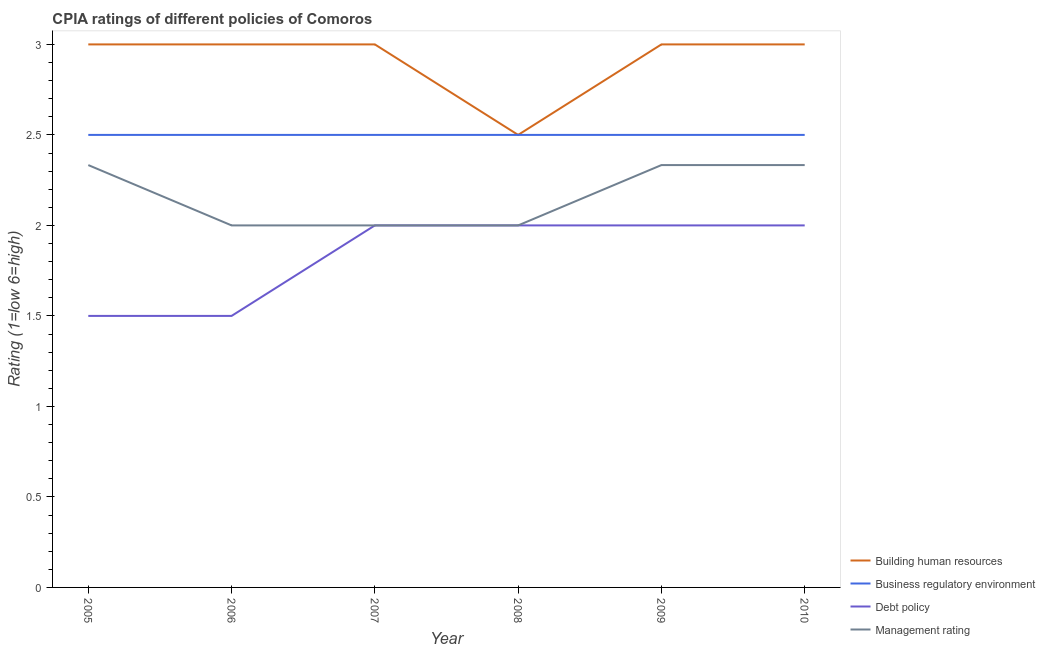How many different coloured lines are there?
Keep it short and to the point. 4. Does the line corresponding to cpia rating of building human resources intersect with the line corresponding to cpia rating of debt policy?
Your response must be concise. No. Across all years, what is the maximum cpia rating of management?
Give a very brief answer. 2.33. In which year was the cpia rating of management minimum?
Provide a short and direct response. 2006. What is the total cpia rating of debt policy in the graph?
Make the answer very short. 11. What is the difference between the cpia rating of building human resources in 2006 and that in 2009?
Offer a terse response. 0. What is the average cpia rating of debt policy per year?
Ensure brevity in your answer.  1.83. In the year 2006, what is the difference between the cpia rating of management and cpia rating of building human resources?
Make the answer very short. -1. What is the difference between the highest and the second highest cpia rating of building human resources?
Your answer should be compact. 0. Is the sum of the cpia rating of debt policy in 2006 and 2007 greater than the maximum cpia rating of management across all years?
Your answer should be very brief. Yes. Is it the case that in every year, the sum of the cpia rating of building human resources and cpia rating of business regulatory environment is greater than the cpia rating of debt policy?
Your response must be concise. Yes. Does the cpia rating of management monotonically increase over the years?
Offer a terse response. No. Is the cpia rating of debt policy strictly greater than the cpia rating of building human resources over the years?
Your answer should be compact. No. Is the cpia rating of building human resources strictly less than the cpia rating of debt policy over the years?
Make the answer very short. No. How many lines are there?
Make the answer very short. 4. What is the difference between two consecutive major ticks on the Y-axis?
Your answer should be compact. 0.5. Are the values on the major ticks of Y-axis written in scientific E-notation?
Your answer should be compact. No. Does the graph contain any zero values?
Provide a succinct answer. No. Where does the legend appear in the graph?
Your answer should be very brief. Bottom right. What is the title of the graph?
Offer a very short reply. CPIA ratings of different policies of Comoros. Does "Japan" appear as one of the legend labels in the graph?
Offer a terse response. No. What is the label or title of the X-axis?
Your answer should be very brief. Year. What is the Rating (1=low 6=high) in Debt policy in 2005?
Your answer should be compact. 1.5. What is the Rating (1=low 6=high) of Management rating in 2005?
Keep it short and to the point. 2.33. What is the Rating (1=low 6=high) of Business regulatory environment in 2006?
Keep it short and to the point. 2.5. What is the Rating (1=low 6=high) of Debt policy in 2006?
Your answer should be very brief. 1.5. What is the Rating (1=low 6=high) in Business regulatory environment in 2007?
Provide a succinct answer. 2.5. What is the Rating (1=low 6=high) in Debt policy in 2007?
Provide a short and direct response. 2. What is the Rating (1=low 6=high) in Business regulatory environment in 2008?
Offer a very short reply. 2.5. What is the Rating (1=low 6=high) in Debt policy in 2008?
Ensure brevity in your answer.  2. What is the Rating (1=low 6=high) in Management rating in 2008?
Keep it short and to the point. 2. What is the Rating (1=low 6=high) in Building human resources in 2009?
Keep it short and to the point. 3. What is the Rating (1=low 6=high) of Debt policy in 2009?
Your response must be concise. 2. What is the Rating (1=low 6=high) in Management rating in 2009?
Keep it short and to the point. 2.33. What is the Rating (1=low 6=high) in Building human resources in 2010?
Ensure brevity in your answer.  3. What is the Rating (1=low 6=high) of Debt policy in 2010?
Offer a terse response. 2. What is the Rating (1=low 6=high) of Management rating in 2010?
Provide a short and direct response. 2.33. Across all years, what is the maximum Rating (1=low 6=high) of Business regulatory environment?
Make the answer very short. 2.5. Across all years, what is the maximum Rating (1=low 6=high) of Debt policy?
Offer a terse response. 2. Across all years, what is the maximum Rating (1=low 6=high) in Management rating?
Your response must be concise. 2.33. Across all years, what is the minimum Rating (1=low 6=high) in Business regulatory environment?
Provide a succinct answer. 2.5. Across all years, what is the minimum Rating (1=low 6=high) of Management rating?
Provide a succinct answer. 2. What is the total Rating (1=low 6=high) of Building human resources in the graph?
Offer a very short reply. 17.5. What is the total Rating (1=low 6=high) of Management rating in the graph?
Provide a succinct answer. 13. What is the difference between the Rating (1=low 6=high) of Business regulatory environment in 2005 and that in 2006?
Provide a succinct answer. 0. What is the difference between the Rating (1=low 6=high) in Debt policy in 2005 and that in 2006?
Provide a succinct answer. 0. What is the difference between the Rating (1=low 6=high) of Business regulatory environment in 2005 and that in 2007?
Keep it short and to the point. 0. What is the difference between the Rating (1=low 6=high) of Debt policy in 2005 and that in 2007?
Your answer should be very brief. -0.5. What is the difference between the Rating (1=low 6=high) of Management rating in 2005 and that in 2007?
Offer a terse response. 0.33. What is the difference between the Rating (1=low 6=high) in Building human resources in 2005 and that in 2008?
Your answer should be very brief. 0.5. What is the difference between the Rating (1=low 6=high) of Business regulatory environment in 2005 and that in 2008?
Ensure brevity in your answer.  0. What is the difference between the Rating (1=low 6=high) in Debt policy in 2005 and that in 2008?
Your answer should be very brief. -0.5. What is the difference between the Rating (1=low 6=high) of Building human resources in 2005 and that in 2009?
Give a very brief answer. 0. What is the difference between the Rating (1=low 6=high) in Building human resources in 2005 and that in 2010?
Your response must be concise. 0. What is the difference between the Rating (1=low 6=high) of Debt policy in 2005 and that in 2010?
Provide a succinct answer. -0.5. What is the difference between the Rating (1=low 6=high) of Building human resources in 2006 and that in 2007?
Offer a very short reply. 0. What is the difference between the Rating (1=low 6=high) in Debt policy in 2006 and that in 2007?
Offer a very short reply. -0.5. What is the difference between the Rating (1=low 6=high) of Management rating in 2006 and that in 2007?
Offer a terse response. 0. What is the difference between the Rating (1=low 6=high) of Building human resources in 2006 and that in 2008?
Ensure brevity in your answer.  0.5. What is the difference between the Rating (1=low 6=high) in Business regulatory environment in 2006 and that in 2008?
Your answer should be very brief. 0. What is the difference between the Rating (1=low 6=high) of Debt policy in 2006 and that in 2008?
Offer a terse response. -0.5. What is the difference between the Rating (1=low 6=high) of Building human resources in 2006 and that in 2009?
Offer a very short reply. 0. What is the difference between the Rating (1=low 6=high) of Building human resources in 2006 and that in 2010?
Your response must be concise. 0. What is the difference between the Rating (1=low 6=high) in Business regulatory environment in 2007 and that in 2008?
Provide a short and direct response. 0. What is the difference between the Rating (1=low 6=high) of Building human resources in 2007 and that in 2009?
Make the answer very short. 0. What is the difference between the Rating (1=low 6=high) in Business regulatory environment in 2007 and that in 2010?
Your response must be concise. 0. What is the difference between the Rating (1=low 6=high) in Building human resources in 2008 and that in 2009?
Provide a short and direct response. -0.5. What is the difference between the Rating (1=low 6=high) of Debt policy in 2008 and that in 2009?
Make the answer very short. 0. What is the difference between the Rating (1=low 6=high) in Building human resources in 2008 and that in 2010?
Offer a terse response. -0.5. What is the difference between the Rating (1=low 6=high) of Business regulatory environment in 2008 and that in 2010?
Offer a very short reply. 0. What is the difference between the Rating (1=low 6=high) of Debt policy in 2008 and that in 2010?
Make the answer very short. 0. What is the difference between the Rating (1=low 6=high) in Building human resources in 2005 and the Rating (1=low 6=high) in Business regulatory environment in 2006?
Your response must be concise. 0.5. What is the difference between the Rating (1=low 6=high) of Building human resources in 2005 and the Rating (1=low 6=high) of Debt policy in 2006?
Provide a succinct answer. 1.5. What is the difference between the Rating (1=low 6=high) in Building human resources in 2005 and the Rating (1=low 6=high) in Management rating in 2006?
Give a very brief answer. 1. What is the difference between the Rating (1=low 6=high) in Business regulatory environment in 2005 and the Rating (1=low 6=high) in Management rating in 2006?
Offer a terse response. 0.5. What is the difference between the Rating (1=low 6=high) of Building human resources in 2005 and the Rating (1=low 6=high) of Debt policy in 2007?
Keep it short and to the point. 1. What is the difference between the Rating (1=low 6=high) of Business regulatory environment in 2005 and the Rating (1=low 6=high) of Debt policy in 2007?
Provide a short and direct response. 0.5. What is the difference between the Rating (1=low 6=high) in Debt policy in 2005 and the Rating (1=low 6=high) in Management rating in 2007?
Provide a succinct answer. -0.5. What is the difference between the Rating (1=low 6=high) in Building human resources in 2005 and the Rating (1=low 6=high) in Management rating in 2008?
Provide a succinct answer. 1. What is the difference between the Rating (1=low 6=high) in Business regulatory environment in 2005 and the Rating (1=low 6=high) in Debt policy in 2008?
Provide a succinct answer. 0.5. What is the difference between the Rating (1=low 6=high) in Building human resources in 2005 and the Rating (1=low 6=high) in Business regulatory environment in 2009?
Ensure brevity in your answer.  0.5. What is the difference between the Rating (1=low 6=high) of Building human resources in 2005 and the Rating (1=low 6=high) of Debt policy in 2009?
Provide a short and direct response. 1. What is the difference between the Rating (1=low 6=high) in Building human resources in 2005 and the Rating (1=low 6=high) in Management rating in 2009?
Your response must be concise. 0.67. What is the difference between the Rating (1=low 6=high) in Business regulatory environment in 2005 and the Rating (1=low 6=high) in Debt policy in 2009?
Keep it short and to the point. 0.5. What is the difference between the Rating (1=low 6=high) in Debt policy in 2005 and the Rating (1=low 6=high) in Management rating in 2009?
Make the answer very short. -0.83. What is the difference between the Rating (1=low 6=high) of Building human resources in 2005 and the Rating (1=low 6=high) of Business regulatory environment in 2010?
Offer a terse response. 0.5. What is the difference between the Rating (1=low 6=high) in Building human resources in 2005 and the Rating (1=low 6=high) in Debt policy in 2010?
Keep it short and to the point. 1. What is the difference between the Rating (1=low 6=high) in Building human resources in 2005 and the Rating (1=low 6=high) in Management rating in 2010?
Your answer should be very brief. 0.67. What is the difference between the Rating (1=low 6=high) in Business regulatory environment in 2005 and the Rating (1=low 6=high) in Debt policy in 2010?
Offer a very short reply. 0.5. What is the difference between the Rating (1=low 6=high) of Debt policy in 2005 and the Rating (1=low 6=high) of Management rating in 2010?
Keep it short and to the point. -0.83. What is the difference between the Rating (1=low 6=high) of Building human resources in 2006 and the Rating (1=low 6=high) of Business regulatory environment in 2007?
Ensure brevity in your answer.  0.5. What is the difference between the Rating (1=low 6=high) in Business regulatory environment in 2006 and the Rating (1=low 6=high) in Management rating in 2007?
Provide a short and direct response. 0.5. What is the difference between the Rating (1=low 6=high) in Debt policy in 2006 and the Rating (1=low 6=high) in Management rating in 2007?
Your answer should be compact. -0.5. What is the difference between the Rating (1=low 6=high) of Building human resources in 2006 and the Rating (1=low 6=high) of Business regulatory environment in 2008?
Give a very brief answer. 0.5. What is the difference between the Rating (1=low 6=high) in Building human resources in 2006 and the Rating (1=low 6=high) in Debt policy in 2008?
Keep it short and to the point. 1. What is the difference between the Rating (1=low 6=high) of Building human resources in 2006 and the Rating (1=low 6=high) of Management rating in 2008?
Make the answer very short. 1. What is the difference between the Rating (1=low 6=high) in Business regulatory environment in 2006 and the Rating (1=low 6=high) in Management rating in 2008?
Ensure brevity in your answer.  0.5. What is the difference between the Rating (1=low 6=high) of Building human resources in 2006 and the Rating (1=low 6=high) of Debt policy in 2009?
Your answer should be compact. 1. What is the difference between the Rating (1=low 6=high) in Building human resources in 2006 and the Rating (1=low 6=high) in Management rating in 2009?
Provide a short and direct response. 0.67. What is the difference between the Rating (1=low 6=high) in Business regulatory environment in 2006 and the Rating (1=low 6=high) in Debt policy in 2009?
Offer a terse response. 0.5. What is the difference between the Rating (1=low 6=high) in Business regulatory environment in 2006 and the Rating (1=low 6=high) in Management rating in 2009?
Your answer should be compact. 0.17. What is the difference between the Rating (1=low 6=high) in Building human resources in 2006 and the Rating (1=low 6=high) in Management rating in 2010?
Make the answer very short. 0.67. What is the difference between the Rating (1=low 6=high) in Business regulatory environment in 2006 and the Rating (1=low 6=high) in Management rating in 2010?
Provide a succinct answer. 0.17. What is the difference between the Rating (1=low 6=high) in Building human resources in 2007 and the Rating (1=low 6=high) in Business regulatory environment in 2008?
Your response must be concise. 0.5. What is the difference between the Rating (1=low 6=high) of Building human resources in 2007 and the Rating (1=low 6=high) of Management rating in 2008?
Offer a terse response. 1. What is the difference between the Rating (1=low 6=high) in Building human resources in 2007 and the Rating (1=low 6=high) in Debt policy in 2009?
Make the answer very short. 1. What is the difference between the Rating (1=low 6=high) of Business regulatory environment in 2007 and the Rating (1=low 6=high) of Debt policy in 2009?
Provide a succinct answer. 0.5. What is the difference between the Rating (1=low 6=high) of Debt policy in 2007 and the Rating (1=low 6=high) of Management rating in 2009?
Offer a terse response. -0.33. What is the difference between the Rating (1=low 6=high) in Building human resources in 2007 and the Rating (1=low 6=high) in Business regulatory environment in 2010?
Your answer should be compact. 0.5. What is the difference between the Rating (1=low 6=high) of Debt policy in 2007 and the Rating (1=low 6=high) of Management rating in 2010?
Make the answer very short. -0.33. What is the difference between the Rating (1=low 6=high) in Building human resources in 2008 and the Rating (1=low 6=high) in Debt policy in 2010?
Keep it short and to the point. 0.5. What is the difference between the Rating (1=low 6=high) in Business regulatory environment in 2008 and the Rating (1=low 6=high) in Management rating in 2010?
Your answer should be compact. 0.17. What is the difference between the Rating (1=low 6=high) in Building human resources in 2009 and the Rating (1=low 6=high) in Management rating in 2010?
Give a very brief answer. 0.67. What is the difference between the Rating (1=low 6=high) of Business regulatory environment in 2009 and the Rating (1=low 6=high) of Management rating in 2010?
Your answer should be very brief. 0.17. What is the average Rating (1=low 6=high) of Building human resources per year?
Your response must be concise. 2.92. What is the average Rating (1=low 6=high) in Debt policy per year?
Provide a succinct answer. 1.83. What is the average Rating (1=low 6=high) of Management rating per year?
Your answer should be compact. 2.17. In the year 2005, what is the difference between the Rating (1=low 6=high) of Building human resources and Rating (1=low 6=high) of Business regulatory environment?
Give a very brief answer. 0.5. In the year 2005, what is the difference between the Rating (1=low 6=high) of Building human resources and Rating (1=low 6=high) of Management rating?
Offer a terse response. 0.67. In the year 2005, what is the difference between the Rating (1=low 6=high) in Business regulatory environment and Rating (1=low 6=high) in Debt policy?
Ensure brevity in your answer.  1. In the year 2005, what is the difference between the Rating (1=low 6=high) in Business regulatory environment and Rating (1=low 6=high) in Management rating?
Offer a terse response. 0.17. In the year 2005, what is the difference between the Rating (1=low 6=high) of Debt policy and Rating (1=low 6=high) of Management rating?
Give a very brief answer. -0.83. In the year 2006, what is the difference between the Rating (1=low 6=high) of Building human resources and Rating (1=low 6=high) of Management rating?
Provide a succinct answer. 1. In the year 2006, what is the difference between the Rating (1=low 6=high) in Business regulatory environment and Rating (1=low 6=high) in Debt policy?
Offer a very short reply. 1. In the year 2006, what is the difference between the Rating (1=low 6=high) in Business regulatory environment and Rating (1=low 6=high) in Management rating?
Your response must be concise. 0.5. In the year 2006, what is the difference between the Rating (1=low 6=high) in Debt policy and Rating (1=low 6=high) in Management rating?
Your answer should be compact. -0.5. In the year 2007, what is the difference between the Rating (1=low 6=high) of Building human resources and Rating (1=low 6=high) of Business regulatory environment?
Make the answer very short. 0.5. In the year 2007, what is the difference between the Rating (1=low 6=high) of Building human resources and Rating (1=low 6=high) of Debt policy?
Give a very brief answer. 1. In the year 2007, what is the difference between the Rating (1=low 6=high) of Business regulatory environment and Rating (1=low 6=high) of Debt policy?
Provide a short and direct response. 0.5. In the year 2007, what is the difference between the Rating (1=low 6=high) in Debt policy and Rating (1=low 6=high) in Management rating?
Provide a short and direct response. 0. In the year 2008, what is the difference between the Rating (1=low 6=high) of Building human resources and Rating (1=low 6=high) of Business regulatory environment?
Offer a very short reply. 0. In the year 2008, what is the difference between the Rating (1=low 6=high) of Building human resources and Rating (1=low 6=high) of Debt policy?
Offer a very short reply. 0.5. In the year 2008, what is the difference between the Rating (1=low 6=high) in Business regulatory environment and Rating (1=low 6=high) in Debt policy?
Provide a succinct answer. 0.5. In the year 2008, what is the difference between the Rating (1=low 6=high) in Business regulatory environment and Rating (1=low 6=high) in Management rating?
Your response must be concise. 0.5. In the year 2008, what is the difference between the Rating (1=low 6=high) of Debt policy and Rating (1=low 6=high) of Management rating?
Offer a terse response. 0. In the year 2009, what is the difference between the Rating (1=low 6=high) in Debt policy and Rating (1=low 6=high) in Management rating?
Ensure brevity in your answer.  -0.33. In the year 2010, what is the difference between the Rating (1=low 6=high) in Building human resources and Rating (1=low 6=high) in Management rating?
Provide a succinct answer. 0.67. In the year 2010, what is the difference between the Rating (1=low 6=high) in Business regulatory environment and Rating (1=low 6=high) in Management rating?
Your answer should be compact. 0.17. What is the ratio of the Rating (1=low 6=high) of Building human resources in 2005 to that in 2006?
Provide a succinct answer. 1. What is the ratio of the Rating (1=low 6=high) of Management rating in 2005 to that in 2006?
Offer a terse response. 1.17. What is the ratio of the Rating (1=low 6=high) in Building human resources in 2005 to that in 2007?
Your response must be concise. 1. What is the ratio of the Rating (1=low 6=high) of Debt policy in 2005 to that in 2007?
Your answer should be compact. 0.75. What is the ratio of the Rating (1=low 6=high) in Building human resources in 2005 to that in 2008?
Your answer should be compact. 1.2. What is the ratio of the Rating (1=low 6=high) in Business regulatory environment in 2005 to that in 2008?
Provide a short and direct response. 1. What is the ratio of the Rating (1=low 6=high) in Building human resources in 2005 to that in 2009?
Your answer should be compact. 1. What is the ratio of the Rating (1=low 6=high) in Business regulatory environment in 2005 to that in 2009?
Offer a very short reply. 1. What is the ratio of the Rating (1=low 6=high) of Debt policy in 2005 to that in 2009?
Your response must be concise. 0.75. What is the ratio of the Rating (1=low 6=high) of Management rating in 2005 to that in 2009?
Give a very brief answer. 1. What is the ratio of the Rating (1=low 6=high) in Business regulatory environment in 2005 to that in 2010?
Offer a very short reply. 1. What is the ratio of the Rating (1=low 6=high) in Debt policy in 2005 to that in 2010?
Your answer should be compact. 0.75. What is the ratio of the Rating (1=low 6=high) in Management rating in 2005 to that in 2010?
Provide a short and direct response. 1. What is the ratio of the Rating (1=low 6=high) of Management rating in 2006 to that in 2007?
Give a very brief answer. 1. What is the ratio of the Rating (1=low 6=high) in Business regulatory environment in 2006 to that in 2008?
Offer a very short reply. 1. What is the ratio of the Rating (1=low 6=high) of Business regulatory environment in 2006 to that in 2009?
Your answer should be very brief. 1. What is the ratio of the Rating (1=low 6=high) of Debt policy in 2006 to that in 2009?
Your answer should be very brief. 0.75. What is the ratio of the Rating (1=low 6=high) of Building human resources in 2006 to that in 2010?
Offer a very short reply. 1. What is the ratio of the Rating (1=low 6=high) of Business regulatory environment in 2006 to that in 2010?
Give a very brief answer. 1. What is the ratio of the Rating (1=low 6=high) in Business regulatory environment in 2007 to that in 2008?
Your answer should be compact. 1. What is the ratio of the Rating (1=low 6=high) in Debt policy in 2007 to that in 2008?
Provide a succinct answer. 1. What is the ratio of the Rating (1=low 6=high) of Building human resources in 2007 to that in 2009?
Ensure brevity in your answer.  1. What is the ratio of the Rating (1=low 6=high) in Business regulatory environment in 2007 to that in 2009?
Provide a succinct answer. 1. What is the ratio of the Rating (1=low 6=high) of Debt policy in 2007 to that in 2009?
Offer a terse response. 1. What is the ratio of the Rating (1=low 6=high) of Business regulatory environment in 2007 to that in 2010?
Provide a succinct answer. 1. What is the ratio of the Rating (1=low 6=high) in Debt policy in 2007 to that in 2010?
Your answer should be compact. 1. What is the ratio of the Rating (1=low 6=high) in Business regulatory environment in 2008 to that in 2009?
Provide a short and direct response. 1. What is the ratio of the Rating (1=low 6=high) of Debt policy in 2008 to that in 2009?
Provide a short and direct response. 1. What is the ratio of the Rating (1=low 6=high) in Management rating in 2008 to that in 2009?
Keep it short and to the point. 0.86. What is the ratio of the Rating (1=low 6=high) in Building human resources in 2008 to that in 2010?
Offer a terse response. 0.83. What is the ratio of the Rating (1=low 6=high) in Debt policy in 2008 to that in 2010?
Your answer should be very brief. 1. What is the ratio of the Rating (1=low 6=high) in Management rating in 2008 to that in 2010?
Offer a terse response. 0.86. What is the ratio of the Rating (1=low 6=high) in Building human resources in 2009 to that in 2010?
Your answer should be compact. 1. What is the ratio of the Rating (1=low 6=high) of Business regulatory environment in 2009 to that in 2010?
Offer a very short reply. 1. What is the ratio of the Rating (1=low 6=high) of Debt policy in 2009 to that in 2010?
Offer a terse response. 1. What is the difference between the highest and the second highest Rating (1=low 6=high) of Business regulatory environment?
Your answer should be very brief. 0. What is the difference between the highest and the second highest Rating (1=low 6=high) in Management rating?
Keep it short and to the point. 0. What is the difference between the highest and the lowest Rating (1=low 6=high) in Building human resources?
Provide a short and direct response. 0.5. What is the difference between the highest and the lowest Rating (1=low 6=high) in Business regulatory environment?
Offer a terse response. 0. What is the difference between the highest and the lowest Rating (1=low 6=high) of Debt policy?
Make the answer very short. 0.5. What is the difference between the highest and the lowest Rating (1=low 6=high) in Management rating?
Your answer should be compact. 0.33. 